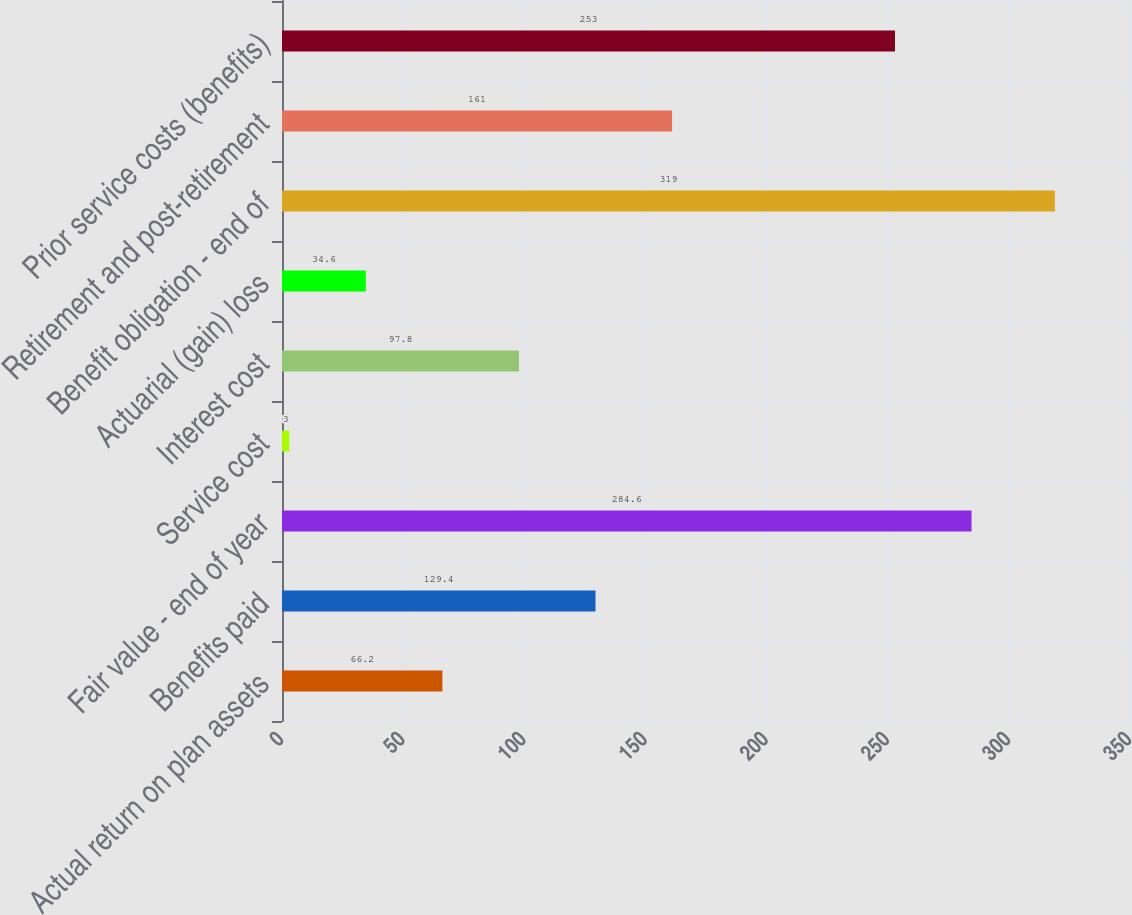<chart> <loc_0><loc_0><loc_500><loc_500><bar_chart><fcel>Actual return on plan assets<fcel>Benefits paid<fcel>Fair value - end of year<fcel>Service cost<fcel>Interest cost<fcel>Actuarial (gain) loss<fcel>Benefit obligation - end of<fcel>Retirement and post-retirement<fcel>Prior service costs (benefits)<nl><fcel>66.2<fcel>129.4<fcel>284.6<fcel>3<fcel>97.8<fcel>34.6<fcel>319<fcel>161<fcel>253<nl></chart> 